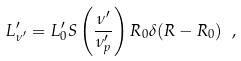<formula> <loc_0><loc_0><loc_500><loc_500>L ^ { \prime } _ { \nu ^ { \prime } } = L ^ { \prime } _ { 0 } S \left ( \frac { \nu ^ { \prime } } { \nu ^ { \prime } _ { p } } \right ) R _ { 0 } \delta ( R - R _ { 0 } ) \ ,</formula> 